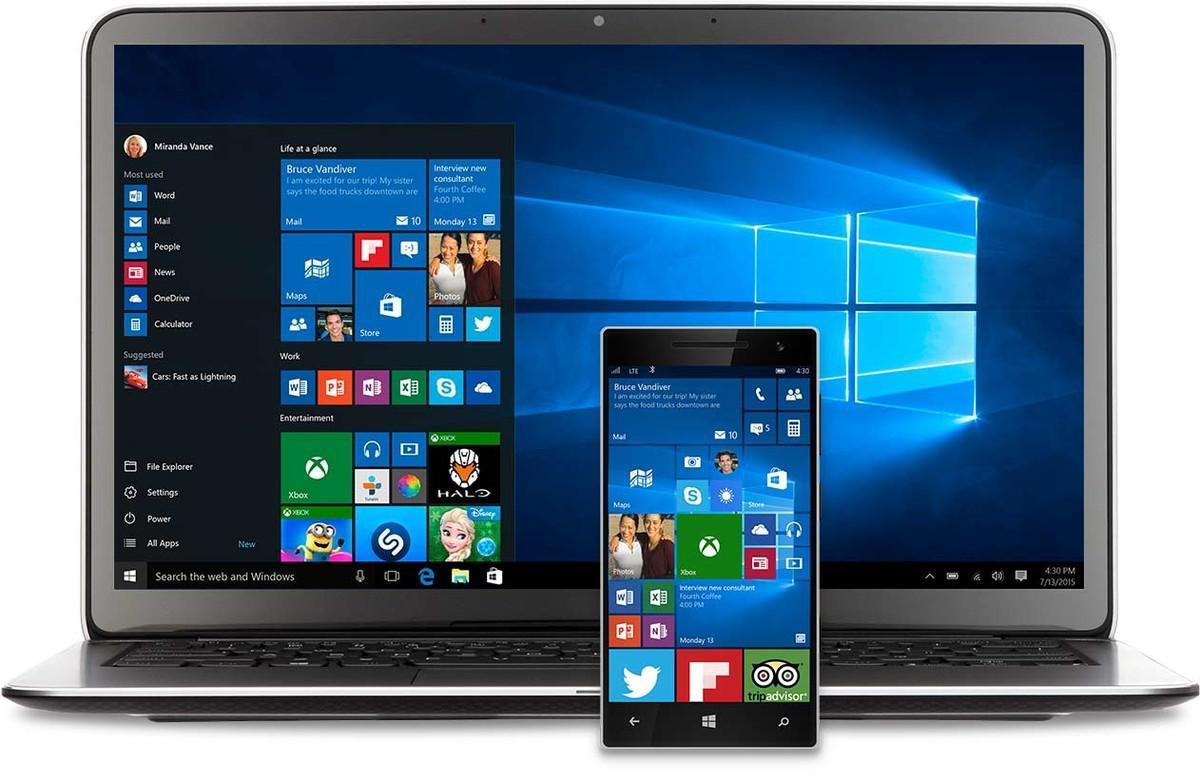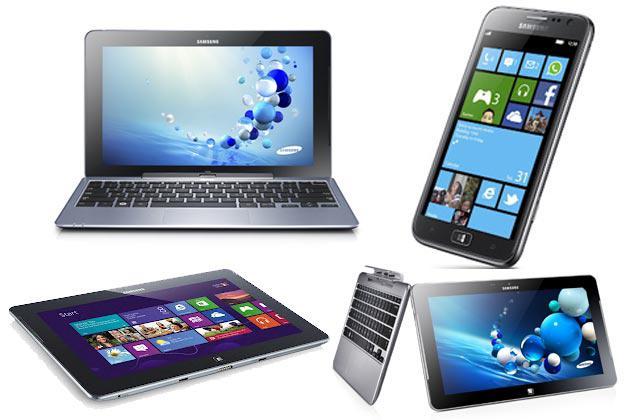The first image is the image on the left, the second image is the image on the right. Examine the images to the left and right. Is the description "There are at least four devices visible in each image." accurate? Answer yes or no. No. 